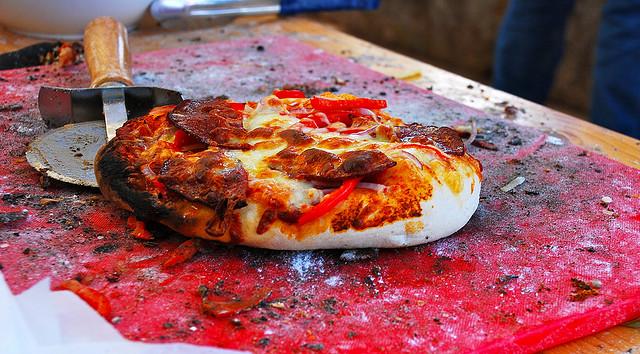Is this Digiorno?
Give a very brief answer. No. What is the tool under the pizza?
Short answer required. Pizza cutter. What food is this?
Be succinct. Pizza. Is the cutting board blue?
Quick response, please. No. 